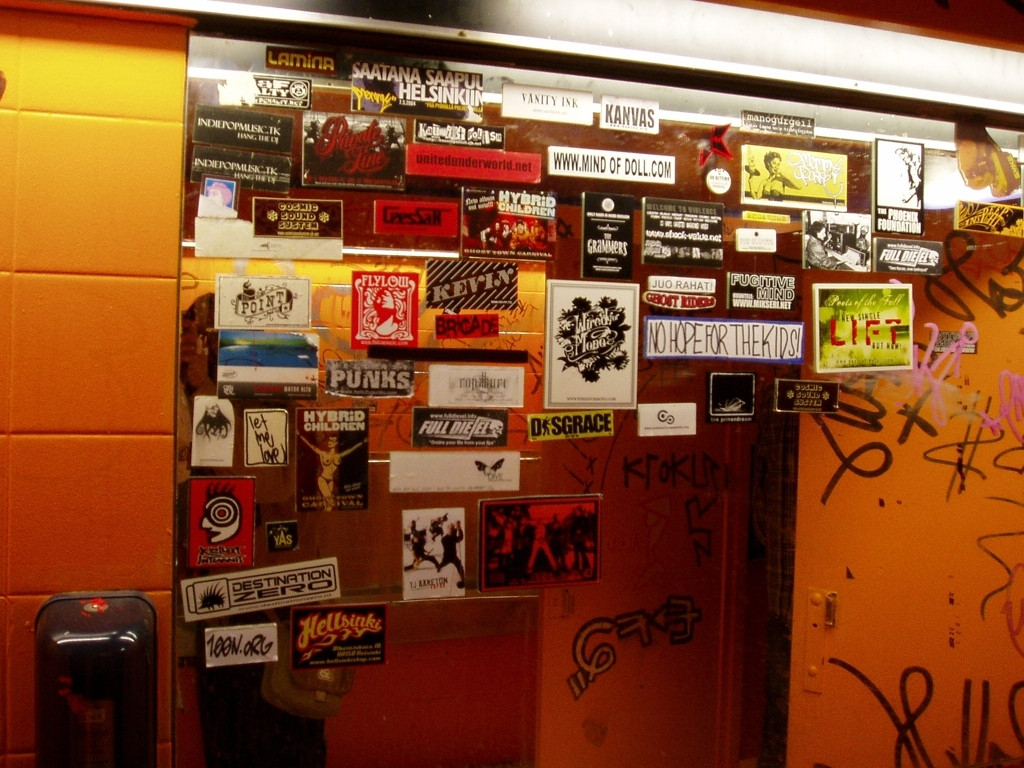Do the colors in the image appear somewhat dull? Yes, the colors in the image do appear somewhat dull. This can be attributed to the lighting conditions and the probable age of the materials shown – mostly stickers and graffiti – which seem to have faded over time. The mixture of man-made lighting and the inherent color palette of browns, yellows, and reds contribute to a muted coloration that lacks vibrancy. 